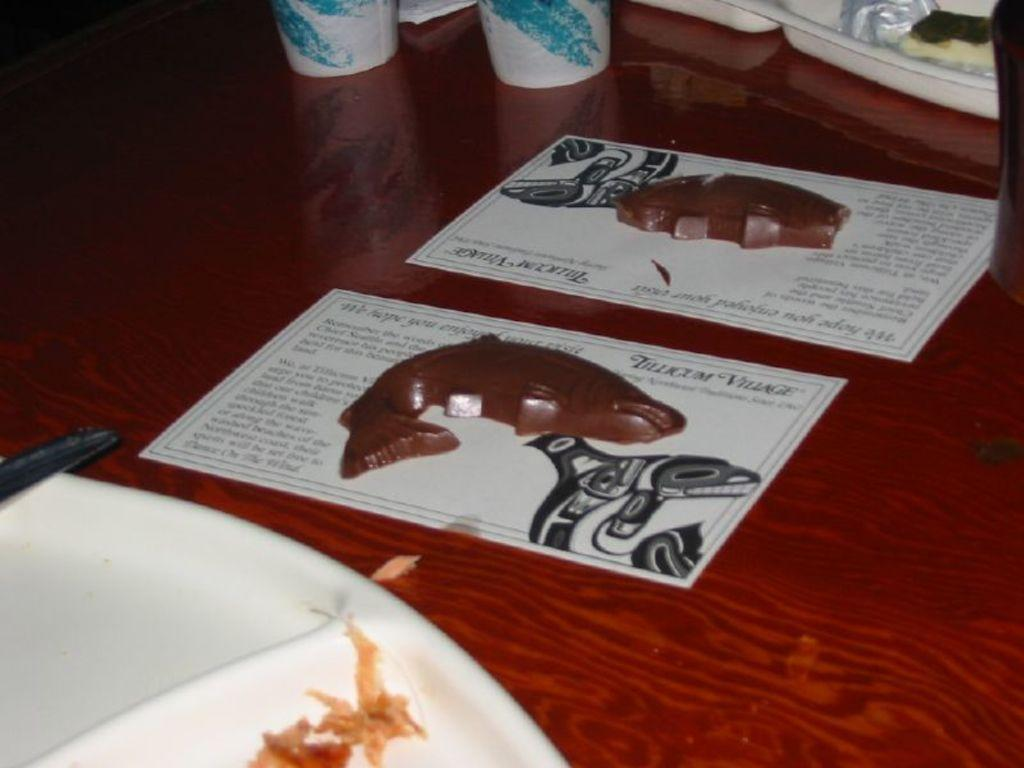What piece of furniture is present in the image? There is a table in the image. What is placed on the table? There is a plate, a paper, and a glass on the table. What type of current can be seen flowing through the glass in the image? There is no current flowing through the glass in the image; it is a glass for holding liquid. 